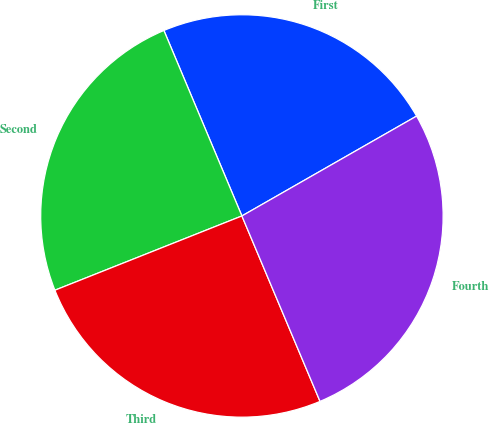<chart> <loc_0><loc_0><loc_500><loc_500><pie_chart><fcel>First<fcel>Second<fcel>Third<fcel>Fourth<nl><fcel>23.07%<fcel>24.68%<fcel>25.33%<fcel>26.92%<nl></chart> 